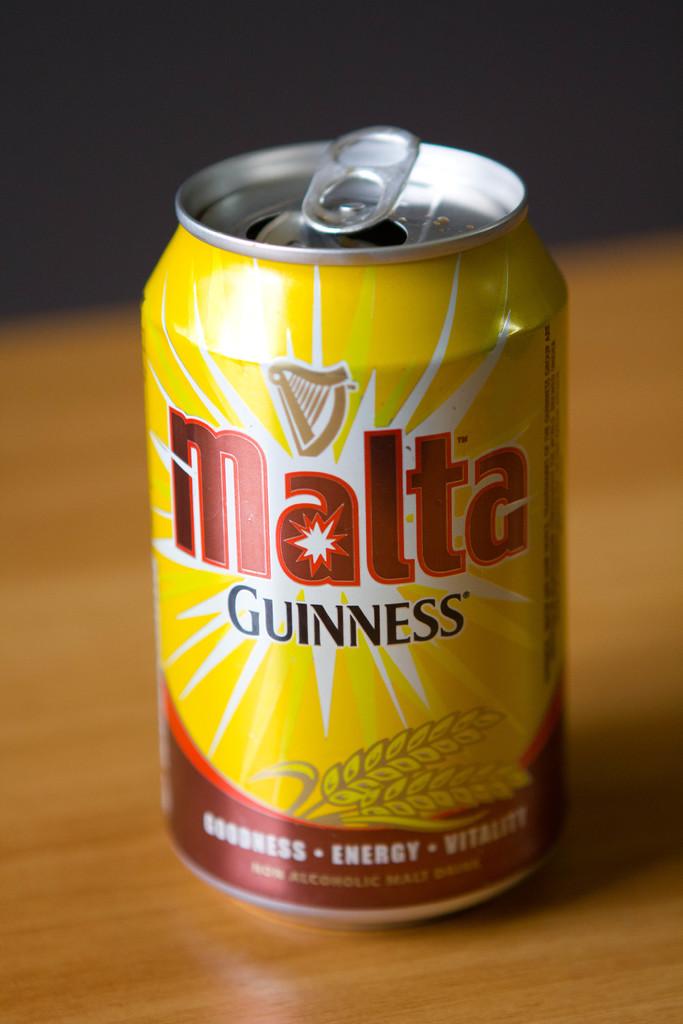What is in the can?
Keep it short and to the point. Guinness. Is it energy drink/?
Make the answer very short. Yes. 